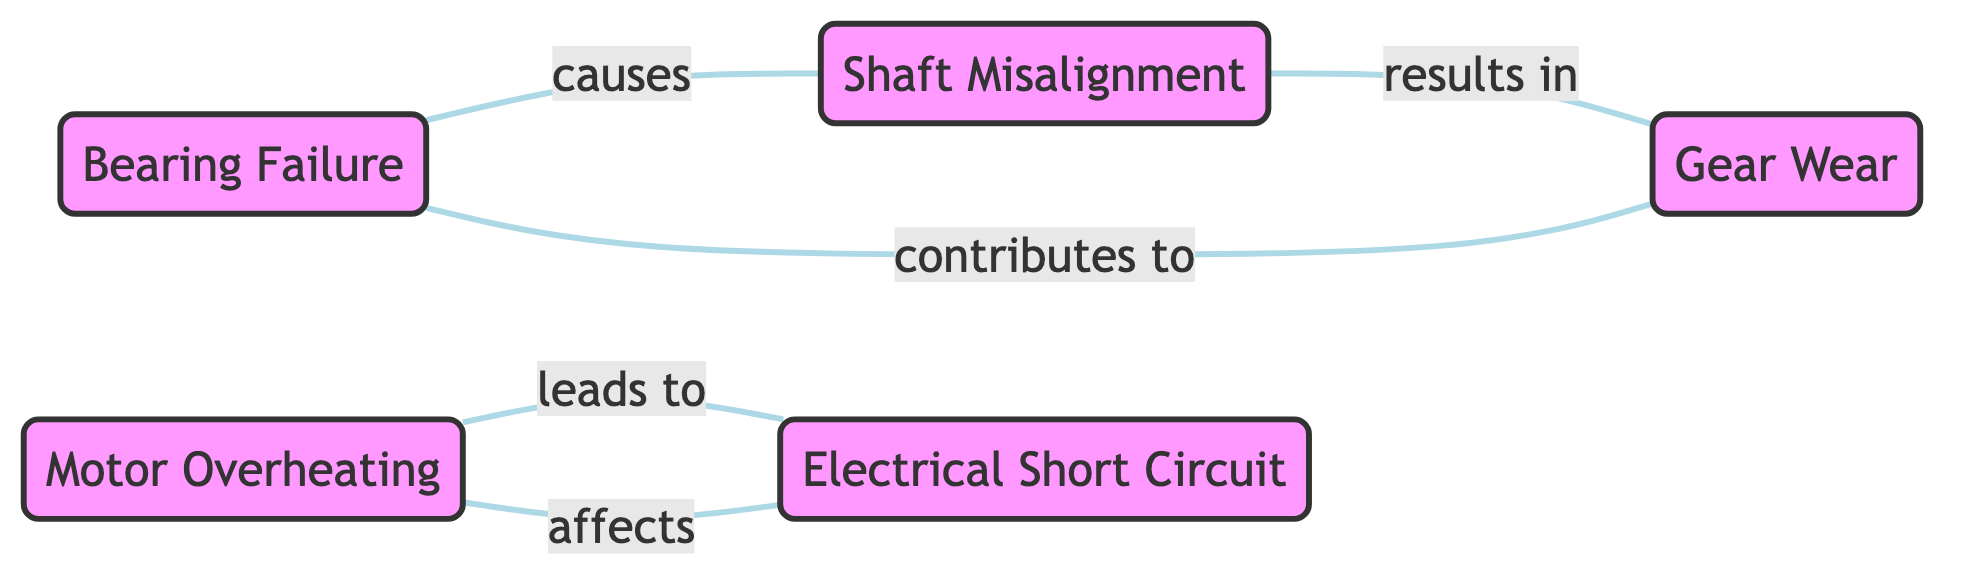What are the total number of nodes in the diagram? There are five unique equipment failure modes indicated in the diagram, represented as nodes: Bearing Failure, Motor Overheating, Shaft Misalignment, Gear Wear, and Electrical Short Circuit. Counting these gives a total of 5 nodes.
Answer: 5 What is the relationship between Bearing Failure and Shaft Misalignment? The diagram shows a direct line connecting Bearing Failure to Shaft Misalignment with the label "causes." This indicates that Bearing Failure causes Shaft Misalignment.
Answer: causes Which nodes contribute to Gear Wear? The diagram indicates a relationship between Gear Wear and Shaft Misalignment, where Shaft Misalignment results in Gear Wear. Therefore, Shaft Misalignment is the contributing factor to Gear Wear.
Answer: Shaft Misalignment How many edges are there in the diagram? The diagram includes the connections (or edges) between various nodes, and upon counting them, we find there are a total of 5 edges connecting these failure modes.
Answer: 5 Which failure mode affects Motor Overheating? According to the diagram, the node Electrical Short Circuit is connected to Motor Overheating with the label "affects." Therefore, Electrical Short Circuit affects Motor Overheating.
Answer: Electrical Short Circuit What failure mode results from Shaft Misalignment? The diagram shows an edge from Shaft Misalignment to Gear Wear, labeled as "results in." This indicates that Gear Wear is the failure mode that results from Shaft Misalignment.
Answer: Gear Wear Which two failure modes are connected by the relationship "leads to"? The edge from Motor Overheating to Electrical Short Circuit is labeled "leads to," indicating a direct connection where Motor Overheating leads to Electrical Short Circuit.
Answer: Motor Overheating and Electrical Short Circuit What is the flow of influence starting from Electrical Short Circuit? Electrical Short Circuit affects Motor Overheating. Motor Overheating doesn't directly lead to another node, but looking at the full graph, it ends up impacting Shaft Misalignment, which then relates to Gear Wear, and finally, Gear Wear contributes back to Bearing Failure. The flow of influence would be: Electrical Short Circuit → Motor Overheating → Shaft Misalignment → Gear Wear → Bearing Failure.
Answer: Electrical Short Circuit → Motor Overheating → Shaft Misalignment → Gear Wear → Bearing Failure 